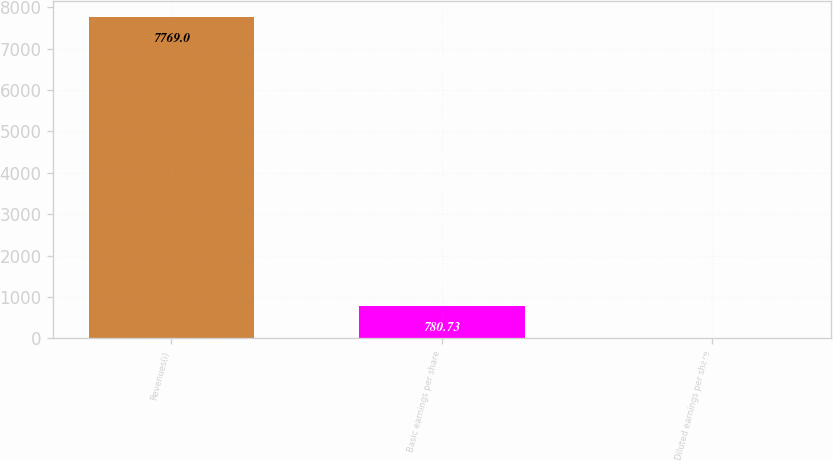Convert chart to OTSL. <chart><loc_0><loc_0><loc_500><loc_500><bar_chart><fcel>Revenues(i)<fcel>Basic earnings per share<fcel>Diluted earnings per share<nl><fcel>7769<fcel>780.73<fcel>4.25<nl></chart> 